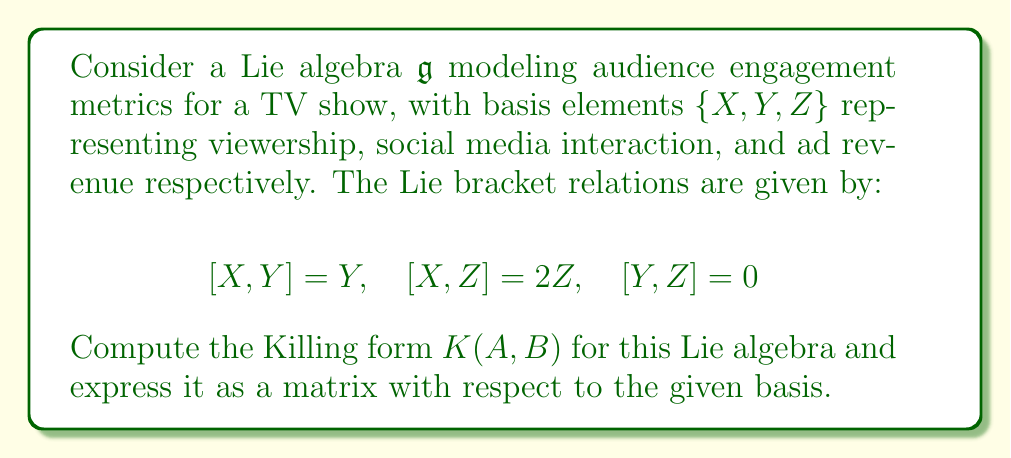Show me your answer to this math problem. To compute the Killing form for this Lie algebra, we need to follow these steps:

1) The Killing form is defined as $K(A, B) = \text{tr}(\text{ad}(A) \circ \text{ad}(B))$, where $\text{ad}(A)$ is the adjoint representation of $A$.

2) First, let's compute the adjoint representations for each basis element:

   For $X$: $\text{ad}(X)(Y) = [X,Y] = Y$, $\text{ad}(X)(Z) = [X,Z] = 2Z$
   $$\text{ad}(X) = \begin{pmatrix} 0 & 0 & 0 \\ 0 & 1 & 0 \\ 0 & 0 & 2 \end{pmatrix}$$

   For $Y$: $\text{ad}(Y)(X) = [Y,X] = -Y$, $\text{ad}(Y)(Z) = [Y,Z] = 0$
   $$\text{ad}(Y) = \begin{pmatrix} 0 & -1 & 0 \\ 0 & 0 & 0 \\ 0 & 0 & 0 \end{pmatrix}$$

   For $Z$: $\text{ad}(Z)(X) = [Z,X] = -2Z$, $\text{ad}(Z)(Y) = [Z,Y] = 0$
   $$\text{ad}(Z) = \begin{pmatrix} 0 & 0 & -2 \\ 0 & 0 & 0 \\ 0 & 0 & 0 \end{pmatrix}$$

3) Now, we compute $K(A, B)$ for all pairs of basis elements:

   $K(X,X) = \text{tr}(\text{ad}(X) \circ \text{ad}(X)) = 0 + 1 + 4 = 5$
   $K(X,Y) = \text{tr}(\text{ad}(X) \circ \text{ad}(Y)) = 0$
   $K(X,Z) = \text{tr}(\text{ad}(X) \circ \text{ad}(Z)) = 0$
   $K(Y,X) = \text{tr}(\text{ad}(Y) \circ \text{ad}(X)) = 0$
   $K(Y,Y) = \text{tr}(\text{ad}(Y) \circ \text{ad}(Y)) = 0$
   $K(Y,Z) = \text{tr}(\text{ad}(Y) \circ \text{ad}(Z)) = 0$
   $K(Z,X) = \text{tr}(\text{ad}(Z) \circ \text{ad}(X)) = 0$
   $K(Z,Y) = \text{tr}(\text{ad}(Z) \circ \text{ad}(Y)) = 0$
   $K(Z,Z) = \text{tr}(\text{ad}(Z) \circ \text{ad}(Z)) = 0$

4) The Killing form can now be expressed as a matrix with respect to the basis $\{X, Y, Z\}$:

   $$K = \begin{pmatrix} 5 & 0 & 0 \\ 0 & 0 & 0 \\ 0 & 0 & 0 \end{pmatrix}$$
Answer: The Killing form for the given Lie algebra, expressed as a matrix with respect to the basis $\{X, Y, Z\}$, is:

$$K = \begin{pmatrix} 5 & 0 & 0 \\ 0 & 0 & 0 \\ 0 & 0 & 0 \end{pmatrix}$$ 